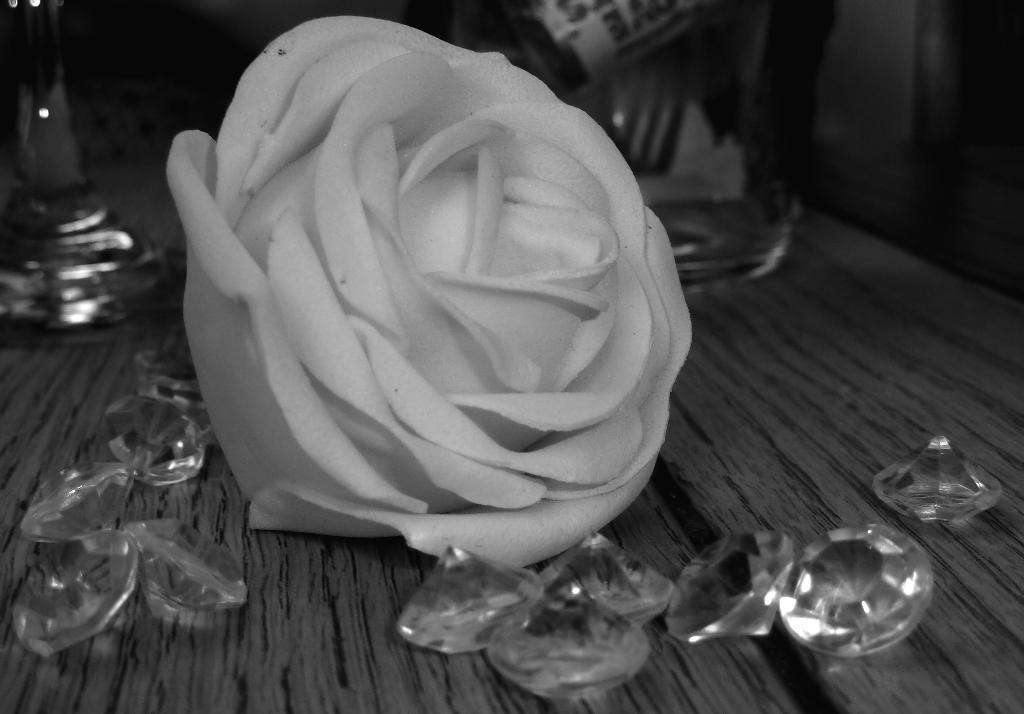What type of table is in the image? There is a wooden table in the image. What is placed on the wooden table? There is a white rose and diamonds on the table. What type of birds can be seen flying around the white rose in the image? There are no birds visible in the image; it only features a wooden table with a white rose and diamonds on it. 